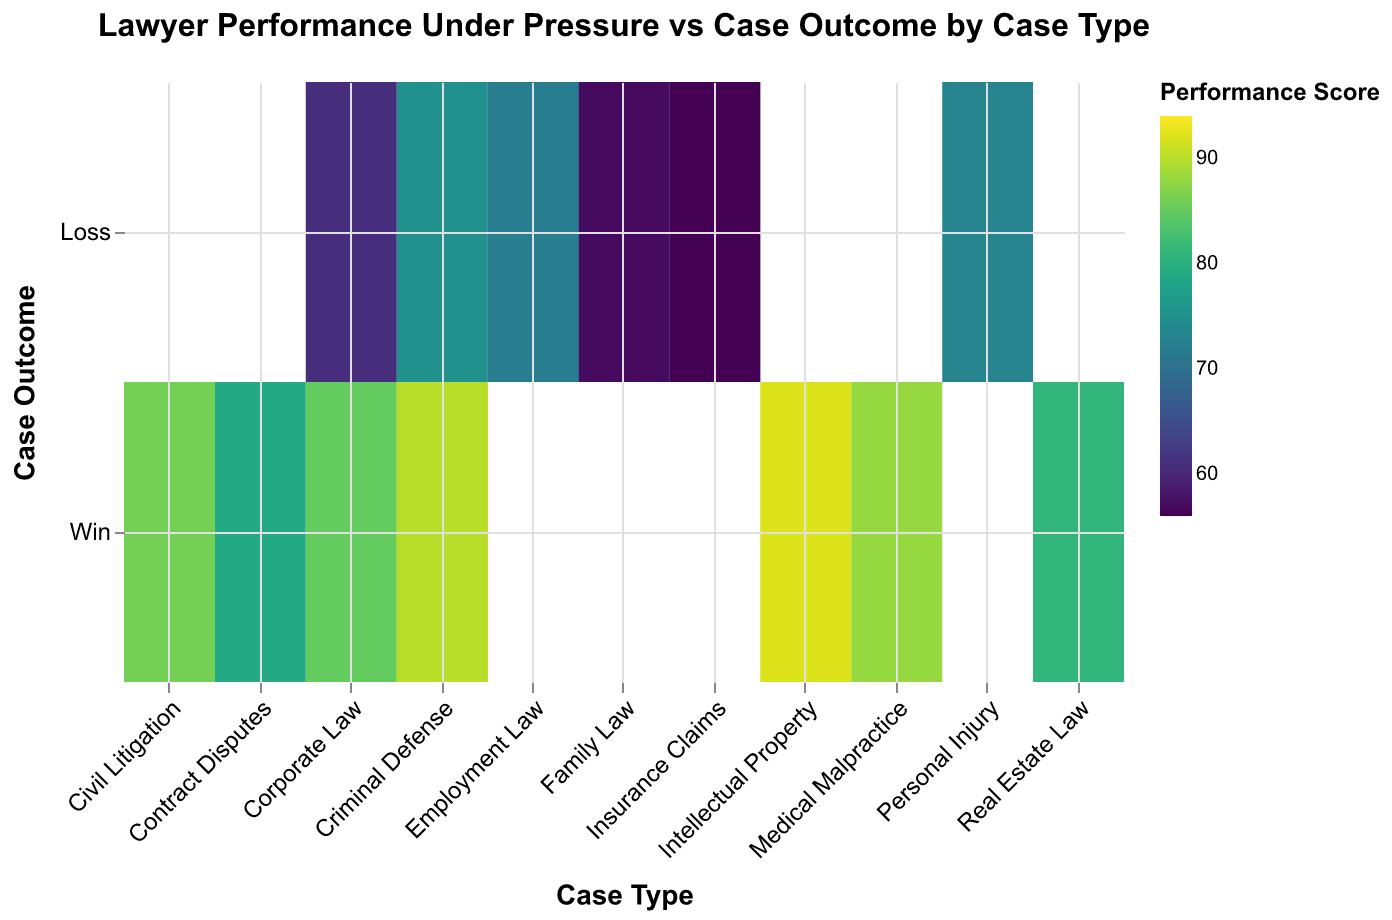What is the title of the heatmap? The title of the heatmap is located at the top of the figure, indicating the main focus or subject of the plot.
Answer: Lawyer Performance Under Pressure vs Case Outcome by Case Type How many case types are represented in the heatmap? To count the case types, look at the x-axis where each case type is listed.
Answer: 9 Which case type has the highest lawyer performance under pressure for a winning outcome? Identify the color representing the highest performance score in the "Win" row across all case types.
Answer: Civil Litigation What is the performance score for "Family Law" cases that resulted in a loss? Look at the intersection of the "Family Law" column and the "Loss" row, and note the corresponding color's value from the legend.
Answer: 57 Are there any "Employment Law" cases that resulted in a win? Check the "Employment Law" column to see if there is a data point in the "Win" row.
Answer: No Which case type has the lowest performance score for a lost case? Find the lowest color value in the "Loss" row across all case types using the color scale.
Answer: Insurance Claims Compare the performance scores for "Corporate Law" in winning and losing outcomes. Which is higher? Identify and compare the colors for the "Corporate Law" column in both the "Win" and "Loss" rows.
Answer: Win What is the average performance score for winning cases across all case types? Sum the performance scores for all winning cases then divide by the number of winning cases.
Answer: Average = (89 + 94 + 85 + 92 + 81 + 88 + 79 + 90 + 82 + 86)/10 = 866/10 = 86.6 How do the performance scores for "Criminal Defense" differ between winning and losing outcomes? Look at the "Criminal Defense" column and compare the values for "Win" and "Loss" rows. Calculate the difference between the winning and losing performance scores.
Answer: Difference = 89 - 75 = 14 